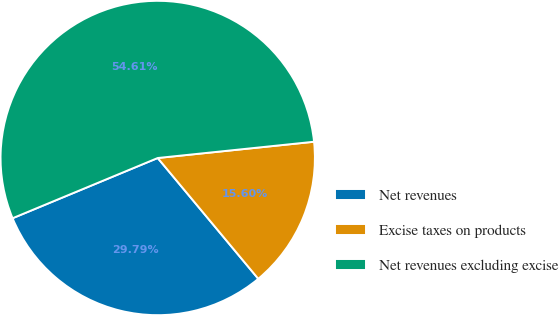<chart> <loc_0><loc_0><loc_500><loc_500><pie_chart><fcel>Net revenues<fcel>Excise taxes on products<fcel>Net revenues excluding excise<nl><fcel>29.79%<fcel>15.6%<fcel>54.61%<nl></chart> 